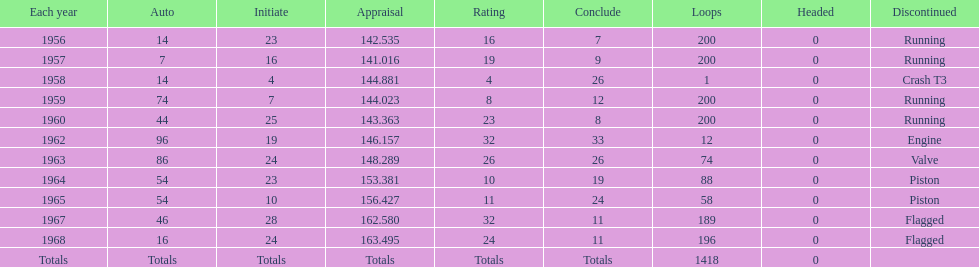What year did he have the same number car as 1964? 1965. 